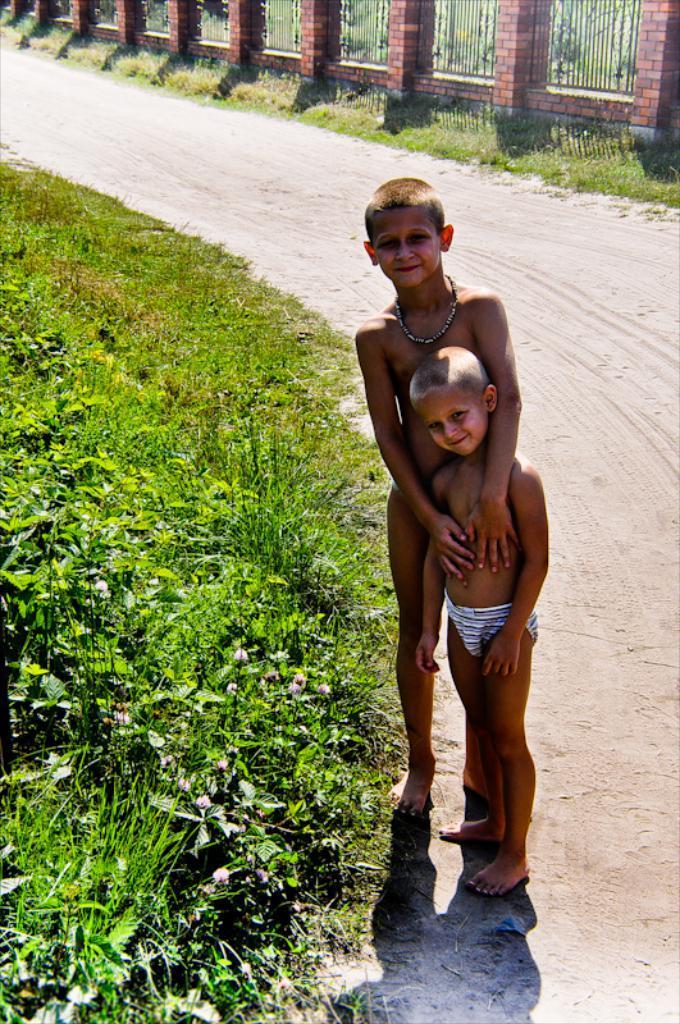Please provide a concise description of this image. In the center of the image there are two kids standing on the road. To the left side of the image there is grass. In the background of the image there is fencing. 